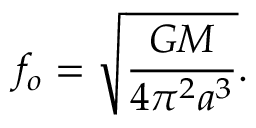<formula> <loc_0><loc_0><loc_500><loc_500>f _ { o } = \sqrt { \frac { G M } { 4 \pi ^ { 2 } a ^ { 3 } } } .</formula> 